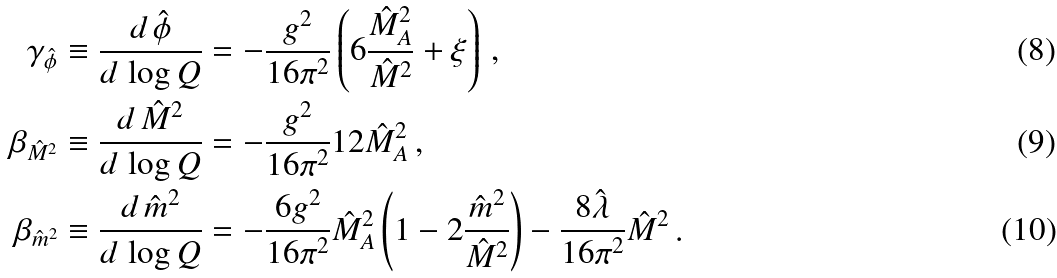Convert formula to latex. <formula><loc_0><loc_0><loc_500><loc_500>\gamma _ { \hat { \phi } } & \equiv \frac { d \, \hat { \phi } } { d \, \log Q } = - \frac { g ^ { 2 } } { 1 6 \pi ^ { 2 } } \left ( 6 \frac { \hat { M } _ { A } ^ { 2 } } { \hat { M } ^ { 2 } } + \xi \right ) \, , \\ \beta _ { \hat { M } ^ { 2 } } & \equiv \frac { d \, \hat { M } ^ { 2 } } { d \, \log Q } = - \frac { g ^ { 2 } } { 1 6 \pi ^ { 2 } } 1 2 \hat { M } _ { A } ^ { 2 } \, , \\ \beta _ { \hat { m } ^ { 2 } } & \equiv \frac { d \, \hat { m } ^ { 2 } } { d \, \log Q } = - \frac { 6 g ^ { 2 } } { 1 6 \pi ^ { 2 } } \hat { M } _ { A } ^ { 2 } \left ( 1 - 2 \frac { \hat { m } ^ { 2 } } { \hat { M } ^ { 2 } } \right ) - \frac { 8 \hat { \lambda } } { 1 6 \pi ^ { 2 } } \hat { M } ^ { 2 } \, .</formula> 